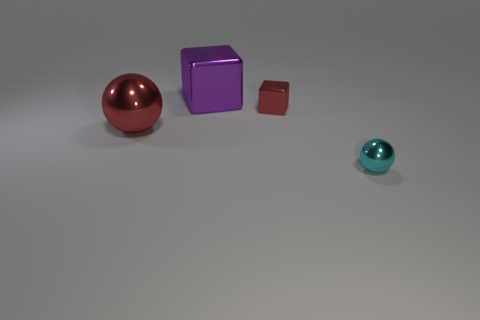Add 2 tiny rubber cubes. How many objects exist? 6 Subtract 0 yellow balls. How many objects are left? 4 Subtract all large balls. Subtract all red metal spheres. How many objects are left? 2 Add 3 big purple shiny cubes. How many big purple shiny cubes are left? 4 Add 1 cyan metallic things. How many cyan metallic things exist? 2 